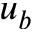Convert formula to latex. <formula><loc_0><loc_0><loc_500><loc_500>u _ { b }</formula> 